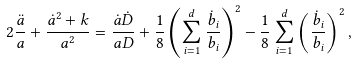Convert formula to latex. <formula><loc_0><loc_0><loc_500><loc_500>2 \frac { \ddot { a } } { a } + \frac { \dot { a } ^ { 2 } + k } { a ^ { 2 } } = \frac { \dot { a } \dot { D } } { a D } + \frac { 1 } { 8 } \left ( \sum _ { i = 1 } ^ { d } \frac { \dot { b } _ { i } } { b _ { i } } \right ) ^ { 2 } - \frac { 1 } { 8 } \sum _ { i = 1 } ^ { d } \left ( \frac { \dot { b } _ { i } } { b _ { i } } \right ) ^ { 2 } ,</formula> 